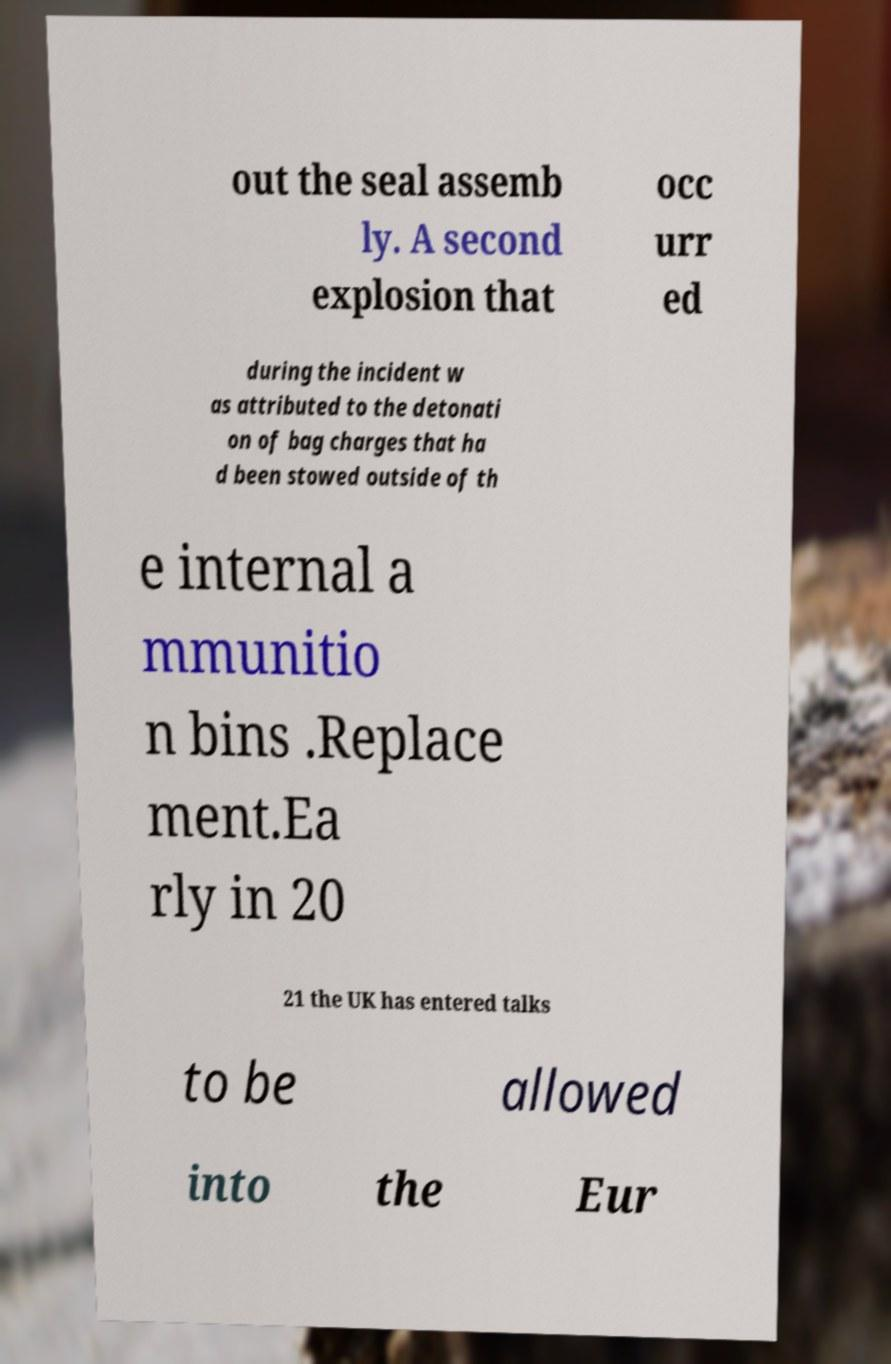For documentation purposes, I need the text within this image transcribed. Could you provide that? out the seal assemb ly. A second explosion that occ urr ed during the incident w as attributed to the detonati on of bag charges that ha d been stowed outside of th e internal a mmunitio n bins .Replace ment.Ea rly in 20 21 the UK has entered talks to be allowed into the Eur 